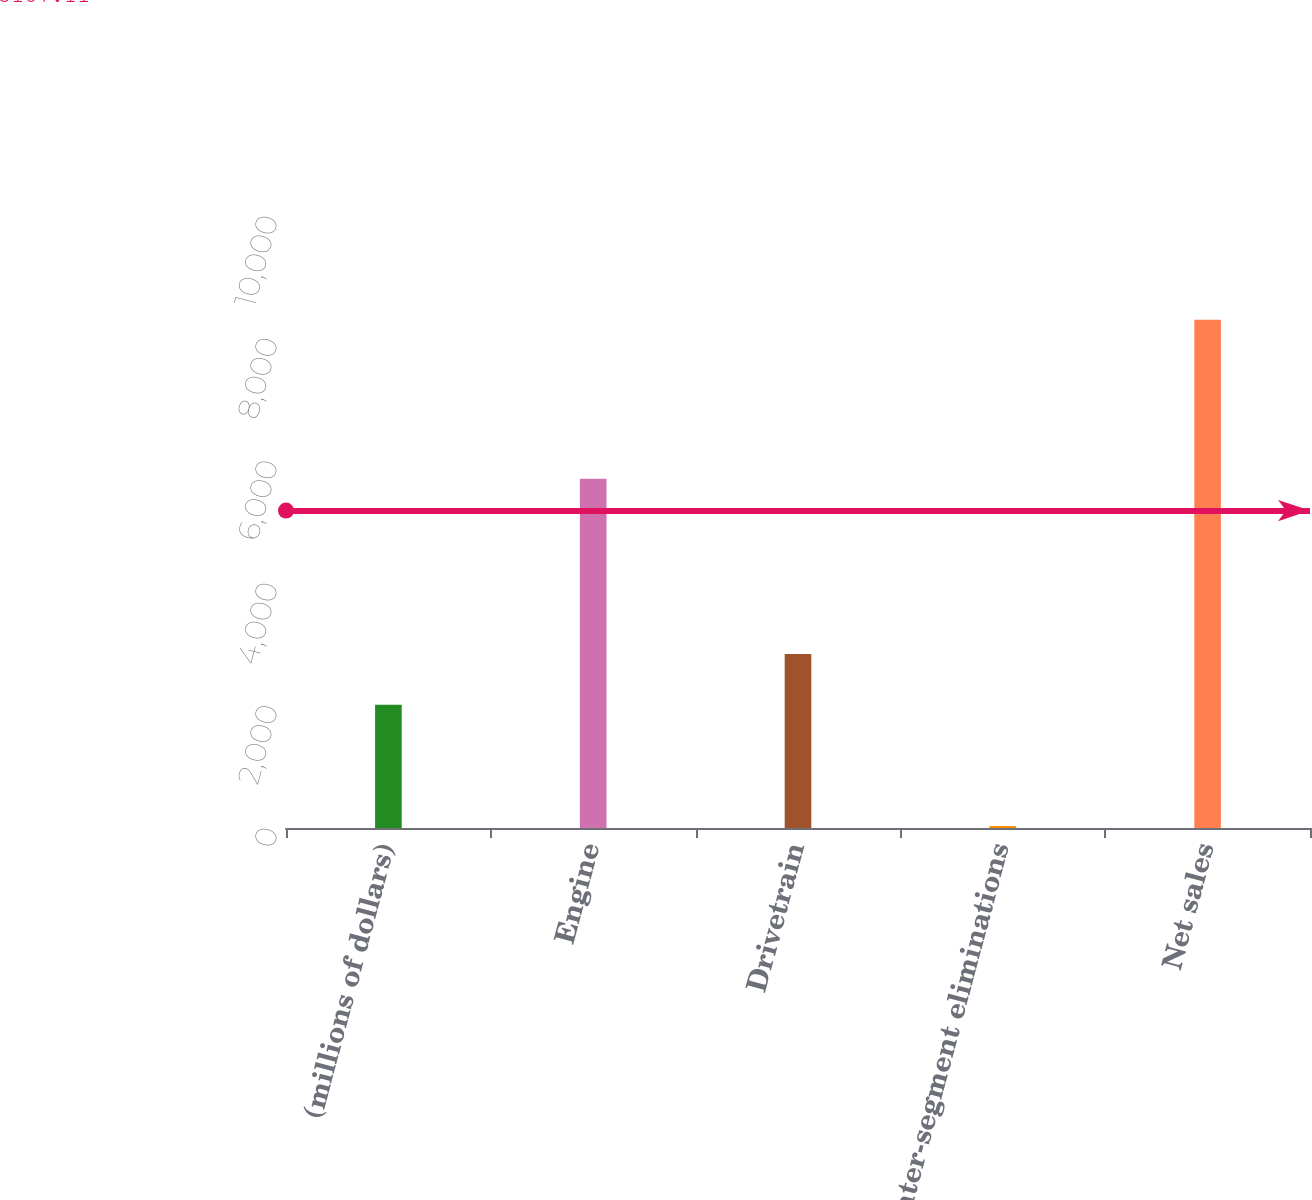Convert chart. <chart><loc_0><loc_0><loc_500><loc_500><bar_chart><fcel>(millions of dollars)<fcel>Engine<fcel>Drivetrain<fcel>Inter-segment eliminations<fcel>Net sales<nl><fcel>2014<fcel>5705.9<fcel>2841.29<fcel>32.2<fcel>8305.1<nl></chart> 